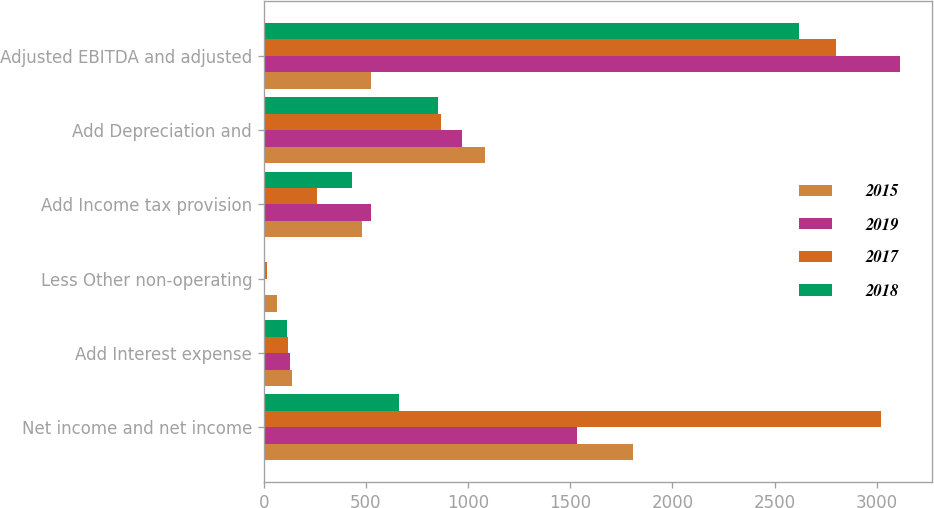<chart> <loc_0><loc_0><loc_500><loc_500><stacked_bar_chart><ecel><fcel>Net income and net income<fcel>Add Interest expense<fcel>Less Other non-operating<fcel>Add Income tax provision<fcel>Add Depreciation and<fcel>Adjusted EBITDA and adjusted<nl><fcel>2015<fcel>1809.4<fcel>137<fcel>66.7<fcel>480.1<fcel>1082.8<fcel>524.3<nl><fcel>2019<fcel>1532.9<fcel>130.5<fcel>5.1<fcel>524.3<fcel>970.7<fcel>3115.5<nl><fcel>2017<fcel>3021.2<fcel>120.6<fcel>16.6<fcel>260.9<fcel>865.8<fcel>2799.2<nl><fcel>2018<fcel>661.5<fcel>115.2<fcel>5.4<fcel>432.6<fcel>854.6<fcel>2621.8<nl></chart> 